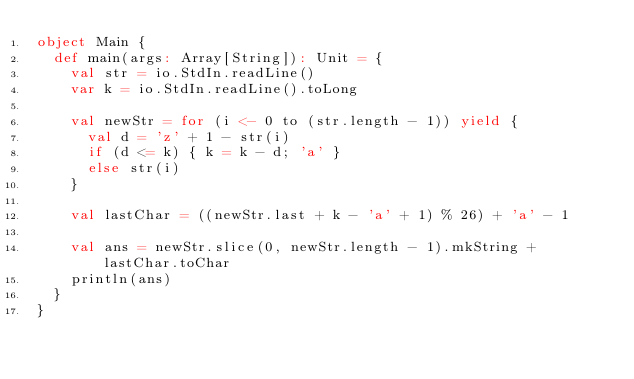Convert code to text. <code><loc_0><loc_0><loc_500><loc_500><_Scala_>object Main {
  def main(args: Array[String]): Unit = {
    val str = io.StdIn.readLine()
    var k = io.StdIn.readLine().toLong

    val newStr = for (i <- 0 to (str.length - 1)) yield {
      val d = 'z' + 1 - str(i)
      if (d <= k) { k = k - d; 'a' }
      else str(i)
    }

    val lastChar = ((newStr.last + k - 'a' + 1) % 26) + 'a' - 1

    val ans = newStr.slice(0, newStr.length - 1).mkString + lastChar.toChar
    println(ans)
  }
}

</code> 